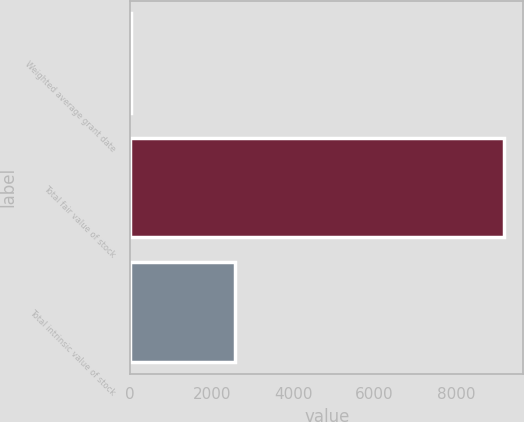Convert chart. <chart><loc_0><loc_0><loc_500><loc_500><bar_chart><fcel>Weighted average grant date<fcel>Total fair value of stock<fcel>Total intrinsic value of stock<nl><fcel>14.54<fcel>9192<fcel>2561<nl></chart> 